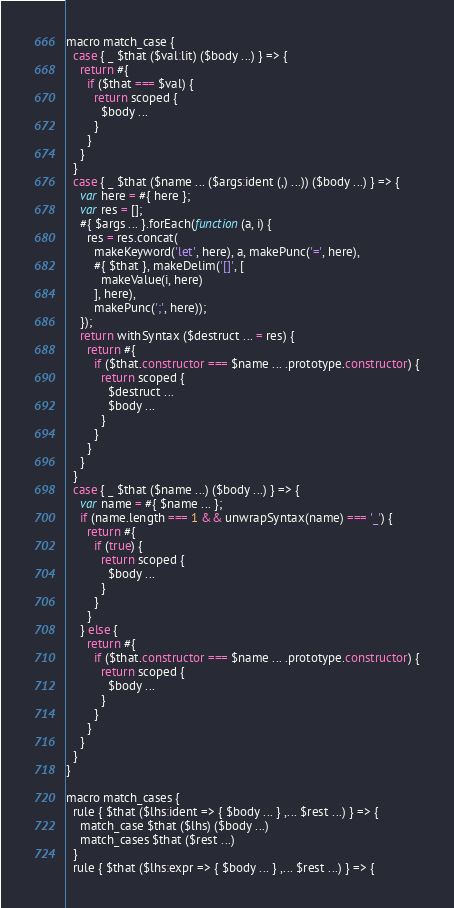Convert code to text. <code><loc_0><loc_0><loc_500><loc_500><_JavaScript_>macro match_case {
  case { _ $that ($val:lit) ($body ...) } => {
    return #{
      if ($that === $val) {
        return scoped {
          $body ...
        }
      }
    }
  }
  case { _ $that ($name ... ($args:ident (,) ...)) ($body ...) } => {
    var here = #{ here };
    var res = [];
    #{ $args ... }.forEach(function(a, i) {
      res = res.concat(
        makeKeyword('let', here), a, makePunc('=', here), 
        #{ $that }, makeDelim('[]', [
          makeValue(i, here)
        ], here),
        makePunc(';', here));
    });
    return withSyntax ($destruct ... = res) {
      return #{
        if ($that.constructor === $name ... .prototype.constructor) {
          return scoped {
            $destruct ...
            $body ...
          }
        }
      }
    }
  }
  case { _ $that ($name ...) ($body ...) } => {
    var name = #{ $name ... };
    if (name.length === 1 && unwrapSyntax(name) === '_') {
      return #{
        if (true) {
          return scoped {
            $body ...
          }
        }
      }
    } else {
      return #{
        if ($that.constructor === $name ... .prototype.constructor) {
          return scoped {
            $body ...
          }
        }
      }
    }
  }
}

macro match_cases {
  rule { $that ($lhs:ident => { $body ... } ,... $rest ...) } => {
    match_case $that ($lhs) ($body ...)
    match_cases $that ($rest ...)
  }
  rule { $that ($lhs:expr => { $body ... } ,... $rest ...) } => {</code> 